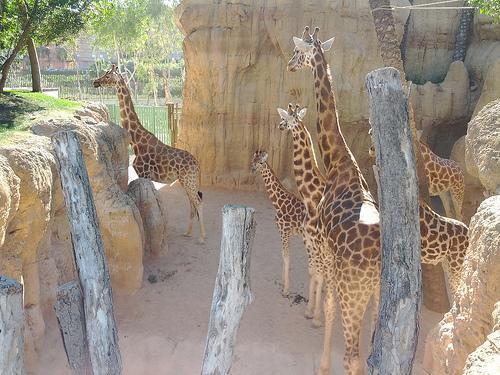How many animals are looking towards the camera?
Give a very brief answer. 1. 